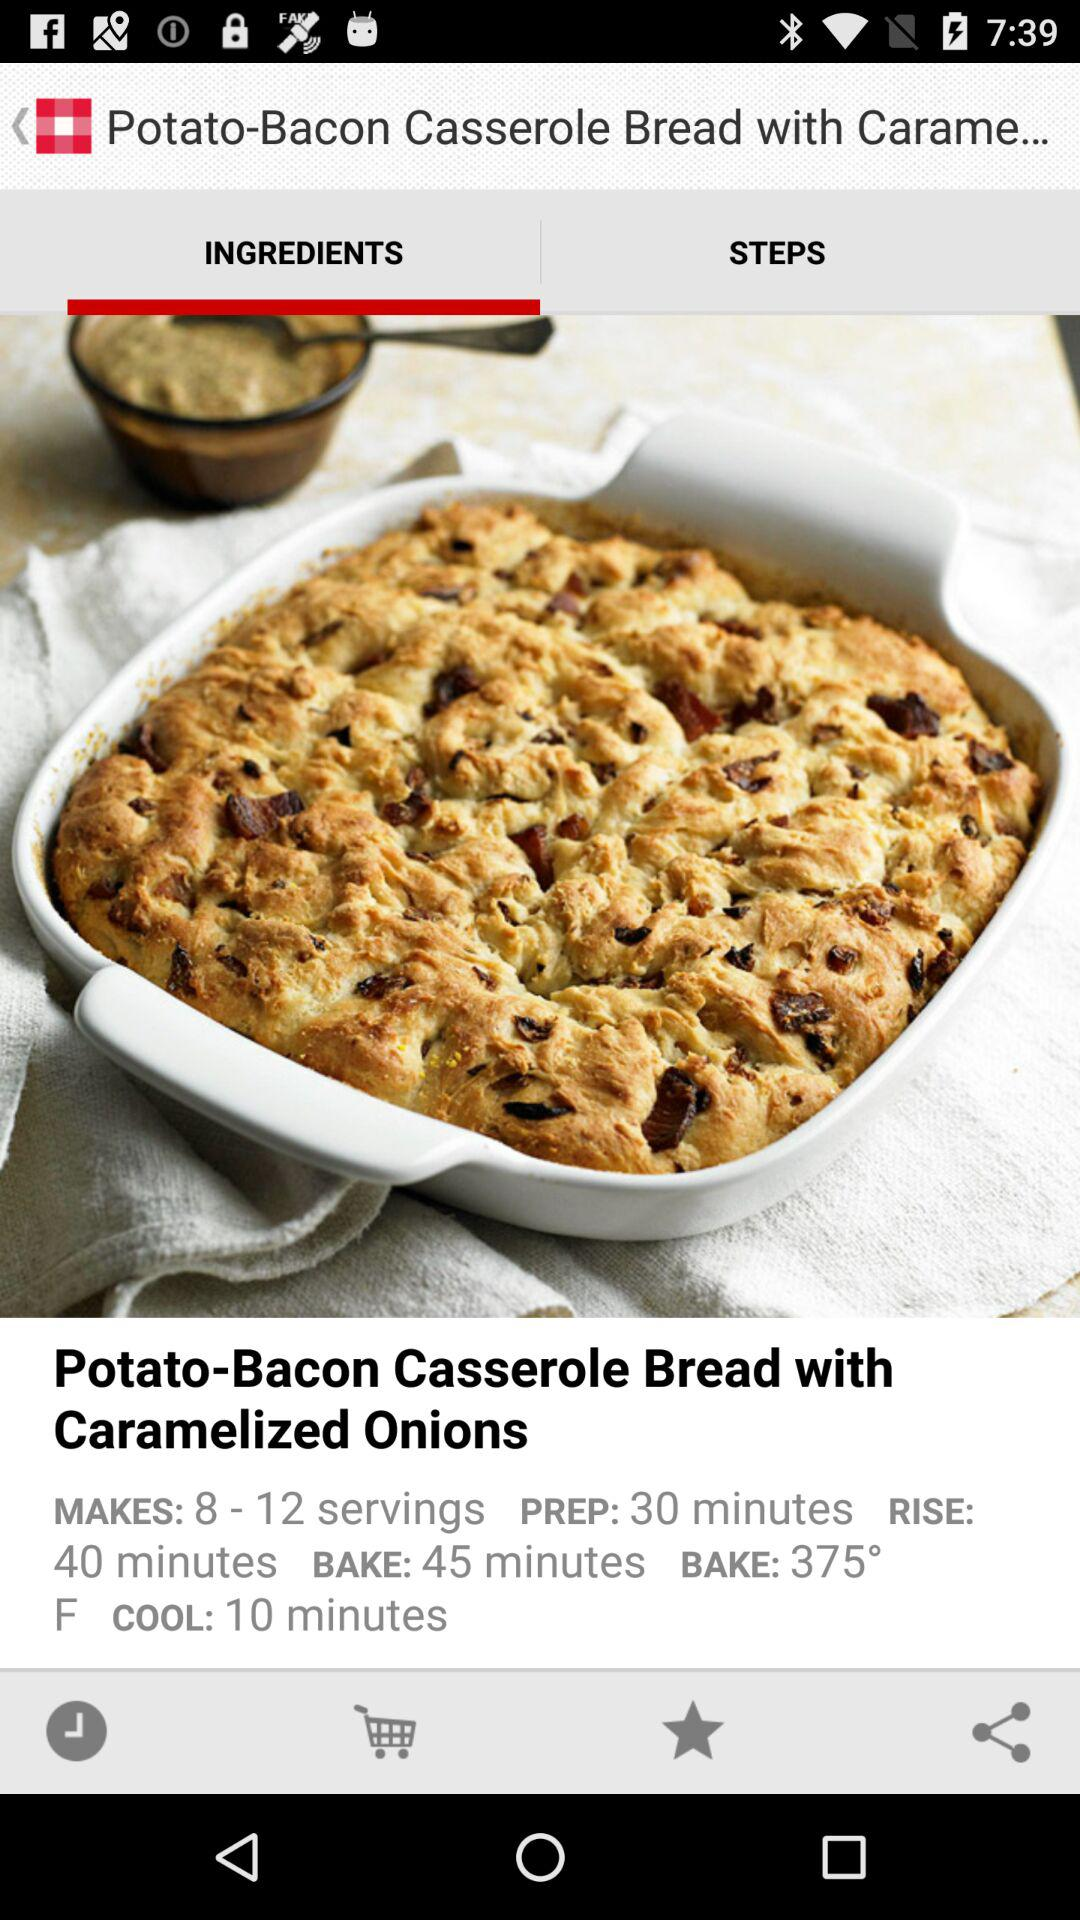How many servings are there? There are 8 to 12 servings. 